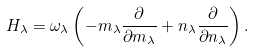Convert formula to latex. <formula><loc_0><loc_0><loc_500><loc_500>H _ { \lambda } = \omega _ { \lambda } \left ( - m _ { \lambda } \frac { \partial } { \partial m _ { \lambda } } + n _ { \lambda } \frac { \partial } { \partial n _ { \lambda } } \right ) .</formula> 